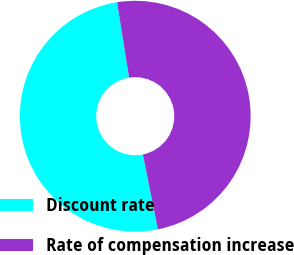Convert chart. <chart><loc_0><loc_0><loc_500><loc_500><pie_chart><fcel>Discount rate<fcel>Rate of compensation increase<nl><fcel>50.62%<fcel>49.38%<nl></chart> 